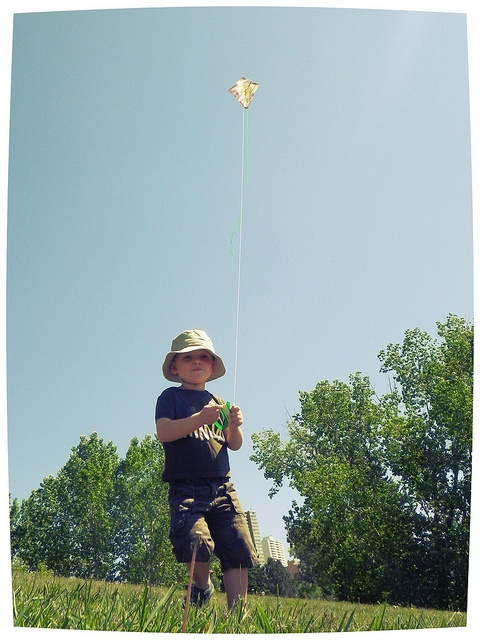Describe the objects in this image and their specific colors. I can see people in white, black, gray, navy, and brown tones and kite in white, lightblue, aquamarine, khaki, and beige tones in this image. 